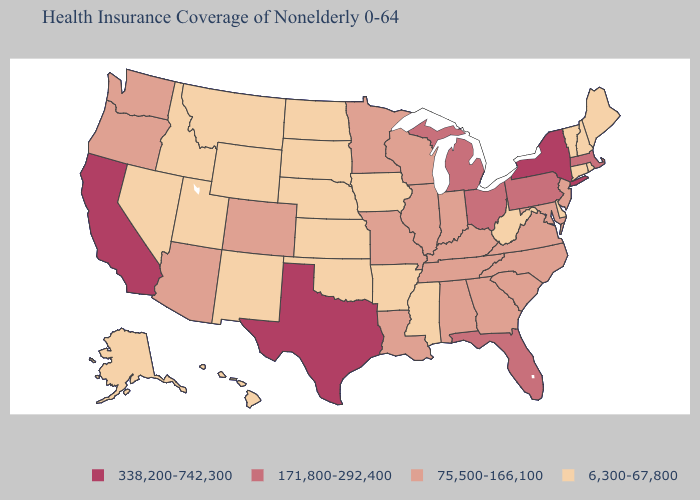How many symbols are there in the legend?
Short answer required. 4. Does Maine have the lowest value in the USA?
Concise answer only. Yes. Does Mississippi have the lowest value in the USA?
Give a very brief answer. Yes. Does Arkansas have the lowest value in the USA?
Short answer required. Yes. What is the lowest value in states that border Montana?
Give a very brief answer. 6,300-67,800. Does Missouri have a lower value than Oklahoma?
Concise answer only. No. Name the states that have a value in the range 6,300-67,800?
Answer briefly. Alaska, Arkansas, Connecticut, Delaware, Hawaii, Idaho, Iowa, Kansas, Maine, Mississippi, Montana, Nebraska, Nevada, New Hampshire, New Mexico, North Dakota, Oklahoma, Rhode Island, South Dakota, Utah, Vermont, West Virginia, Wyoming. Among the states that border Iowa , which have the lowest value?
Write a very short answer. Nebraska, South Dakota. What is the value of New Mexico?
Quick response, please. 6,300-67,800. Does the map have missing data?
Be succinct. No. What is the value of Connecticut?
Answer briefly. 6,300-67,800. Among the states that border Illinois , which have the lowest value?
Quick response, please. Iowa. What is the value of Colorado?
Be succinct. 75,500-166,100. Among the states that border Texas , which have the lowest value?
Keep it brief. Arkansas, New Mexico, Oklahoma. 